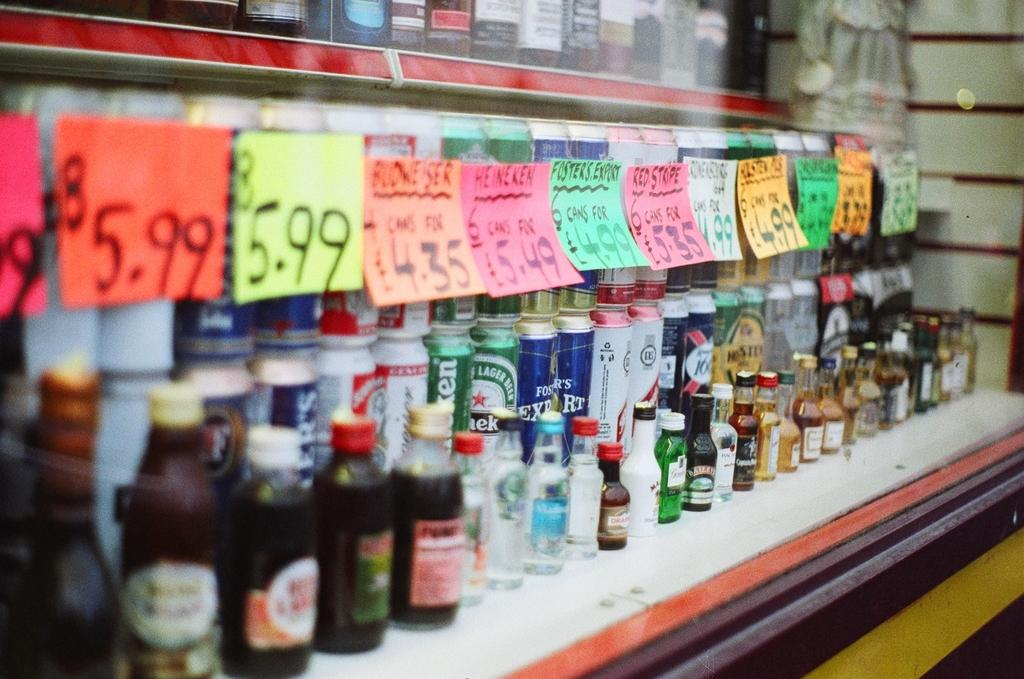<image>
Create a compact narrative representing the image presented. Different types of beer that are on sale for as low as 5.99 